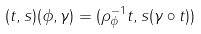Convert formula to latex. <formula><loc_0><loc_0><loc_500><loc_500>( t , s ) ( \phi , \gamma ) = ( \rho _ { \phi } ^ { - 1 } t , s ( \gamma \circ t ) )</formula> 